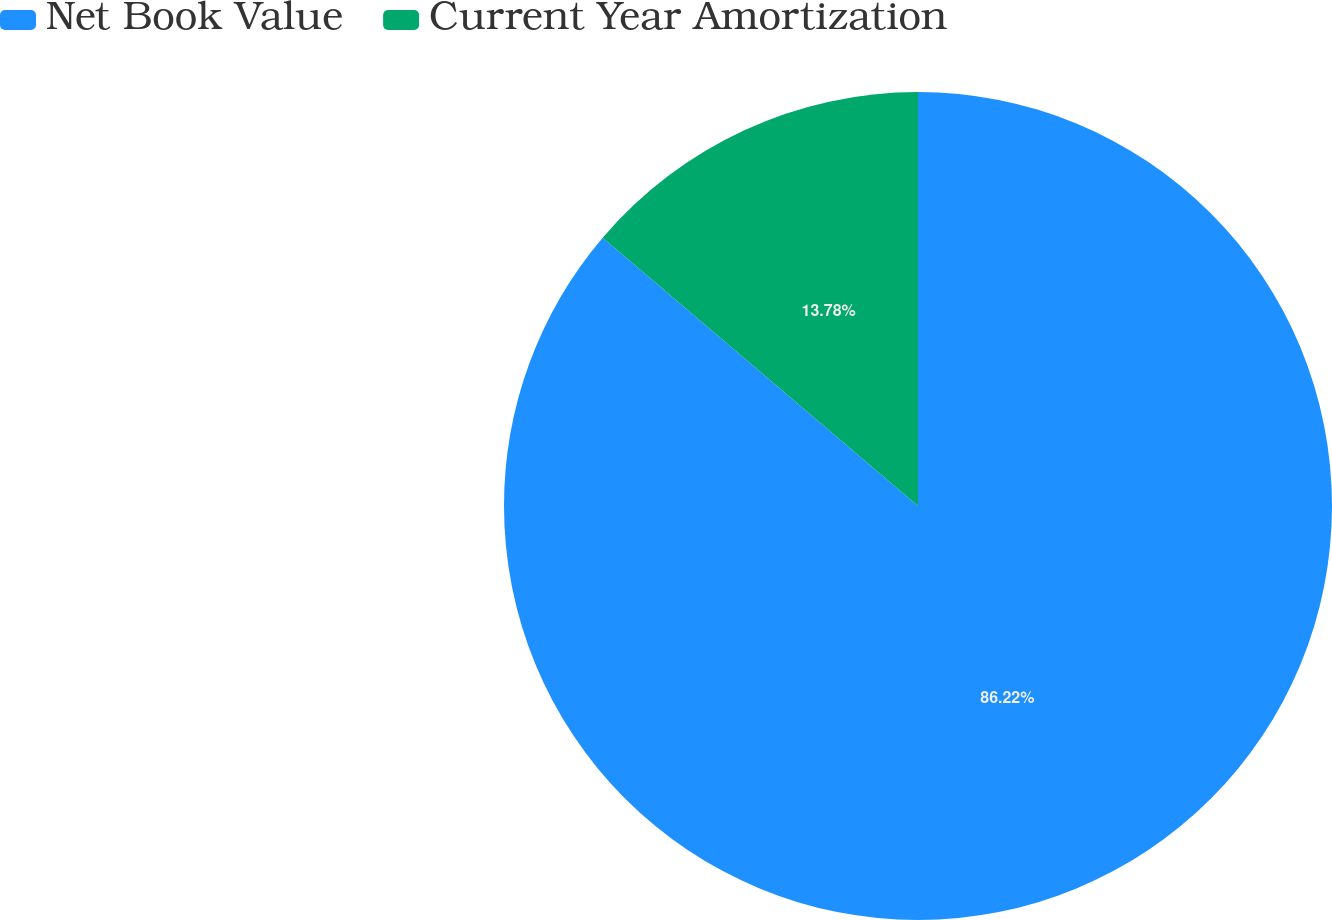Convert chart. <chart><loc_0><loc_0><loc_500><loc_500><pie_chart><fcel>Net Book Value<fcel>Current Year Amortization<nl><fcel>86.22%<fcel>13.78%<nl></chart> 